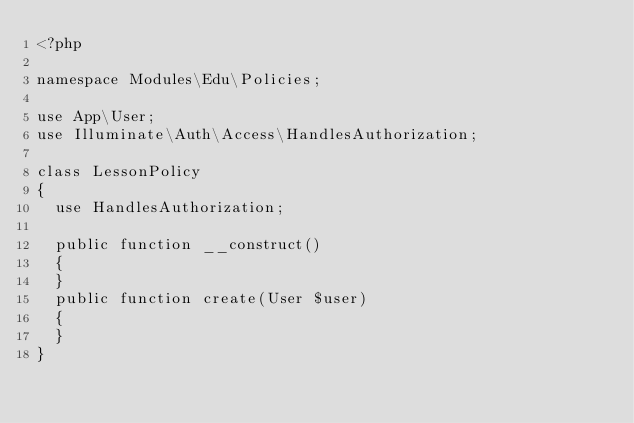<code> <loc_0><loc_0><loc_500><loc_500><_PHP_><?php

namespace Modules\Edu\Policies;

use App\User;
use Illuminate\Auth\Access\HandlesAuthorization;

class LessonPolicy
{
  use HandlesAuthorization;

  public function __construct()
  {
  }
  public function create(User $user)
  {
  }
}
</code> 